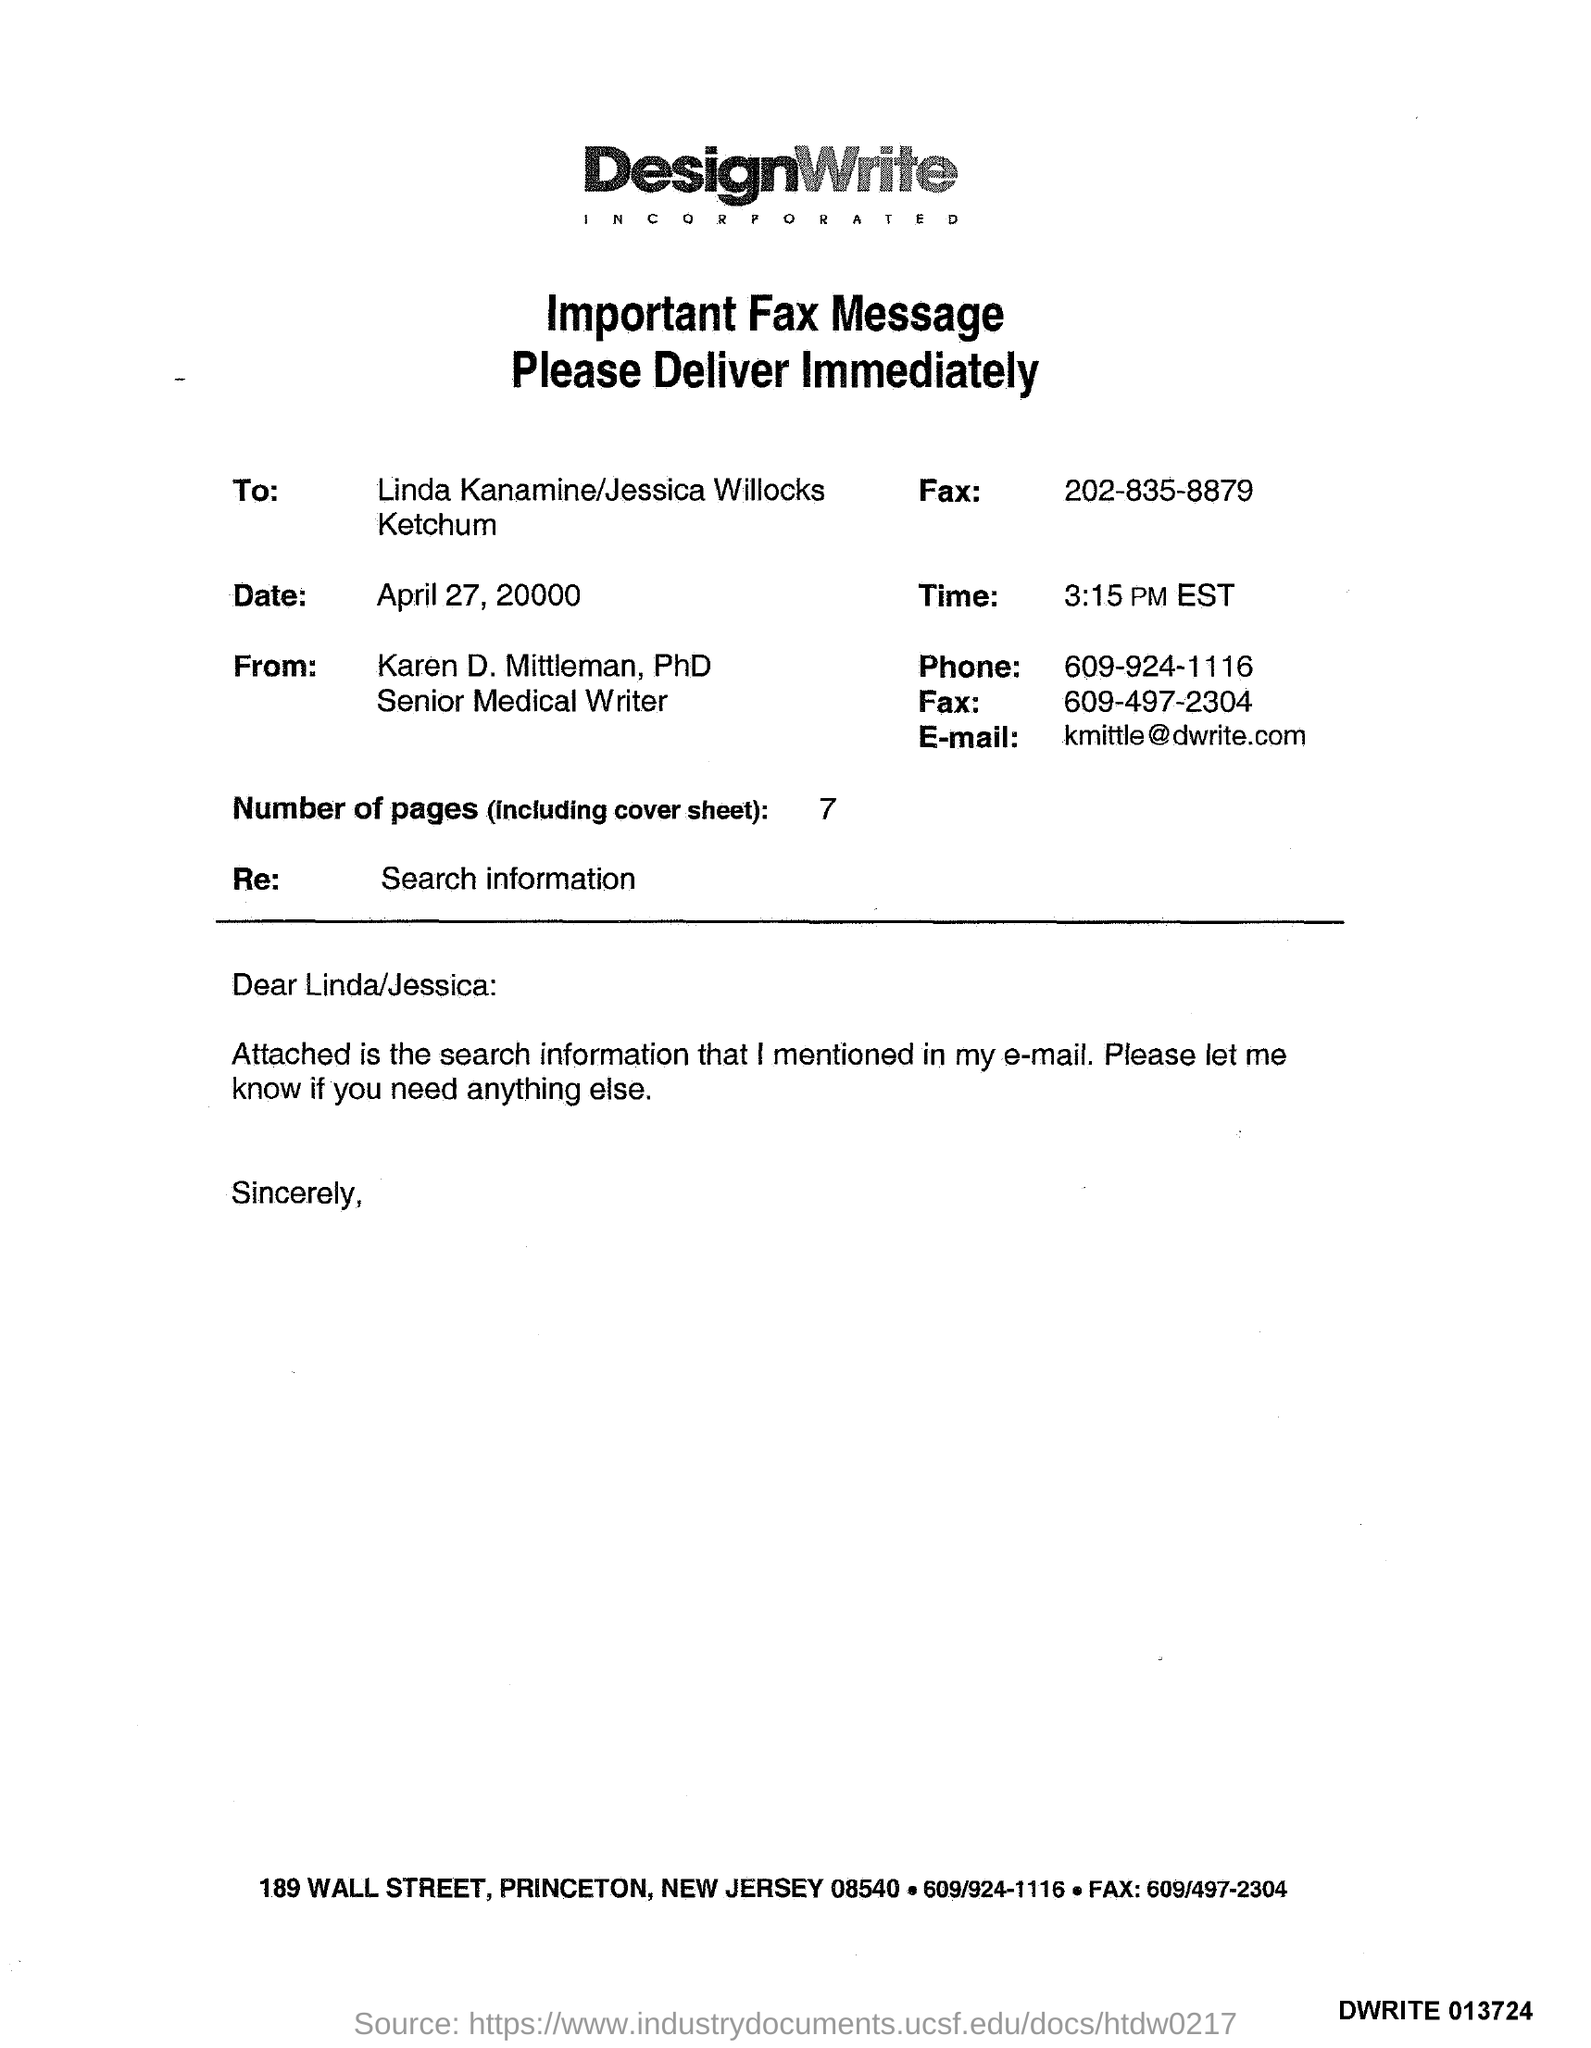Who is the Memorandum addressed to ?
Provide a short and direct response. Linda Kanamine/Jessica Willocks Ketchum. What is the Receiver Fax Number ?
Your answer should be very brief. 202-835-8879. What is the date mentioned in the  document ?
Keep it short and to the point. April 27, 20000. Who is the Memorandum from ?
Offer a very short reply. Karen D. Mittleman,. What is the Sender Fax Number ?
Provide a succinct answer. 609-497-2304. How many Pages are there in this sheet ?
Make the answer very short. 7. What is written in the "Re" field ?
Give a very brief answer. Search information. What is the Sender Phone Number ?
Your answer should be compact. 609-924-1116. 